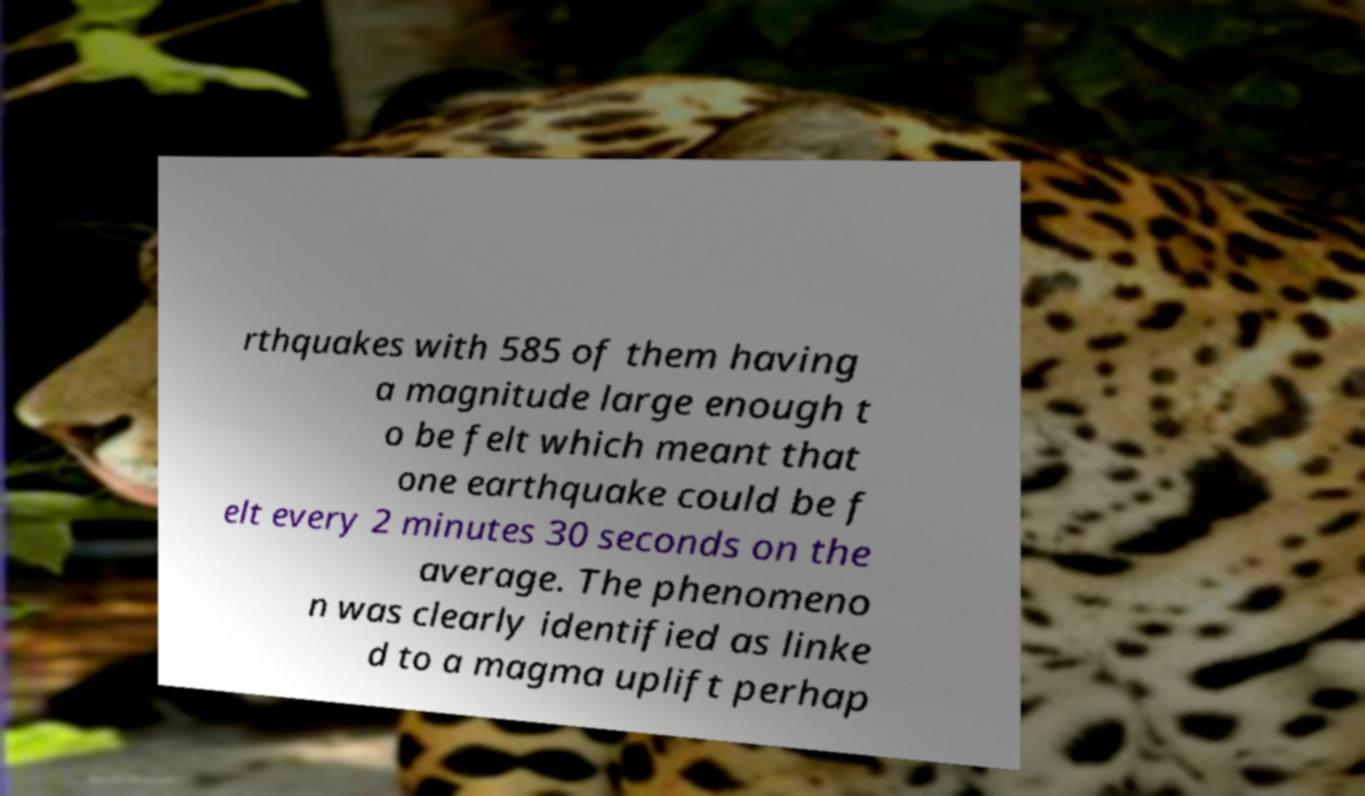Please identify and transcribe the text found in this image. rthquakes with 585 of them having a magnitude large enough t o be felt which meant that one earthquake could be f elt every 2 minutes 30 seconds on the average. The phenomeno n was clearly identified as linke d to a magma uplift perhap 